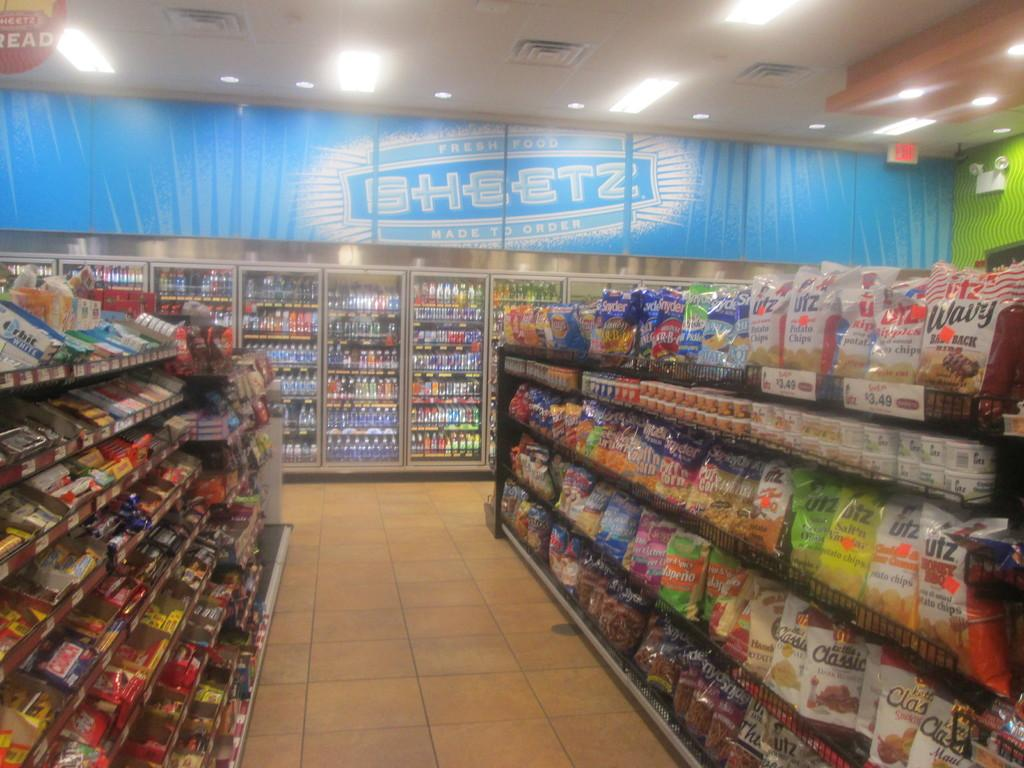<image>
Render a clear and concise summary of the photo. an aisle of snacks and a blue sign reading Sheetz at the back 